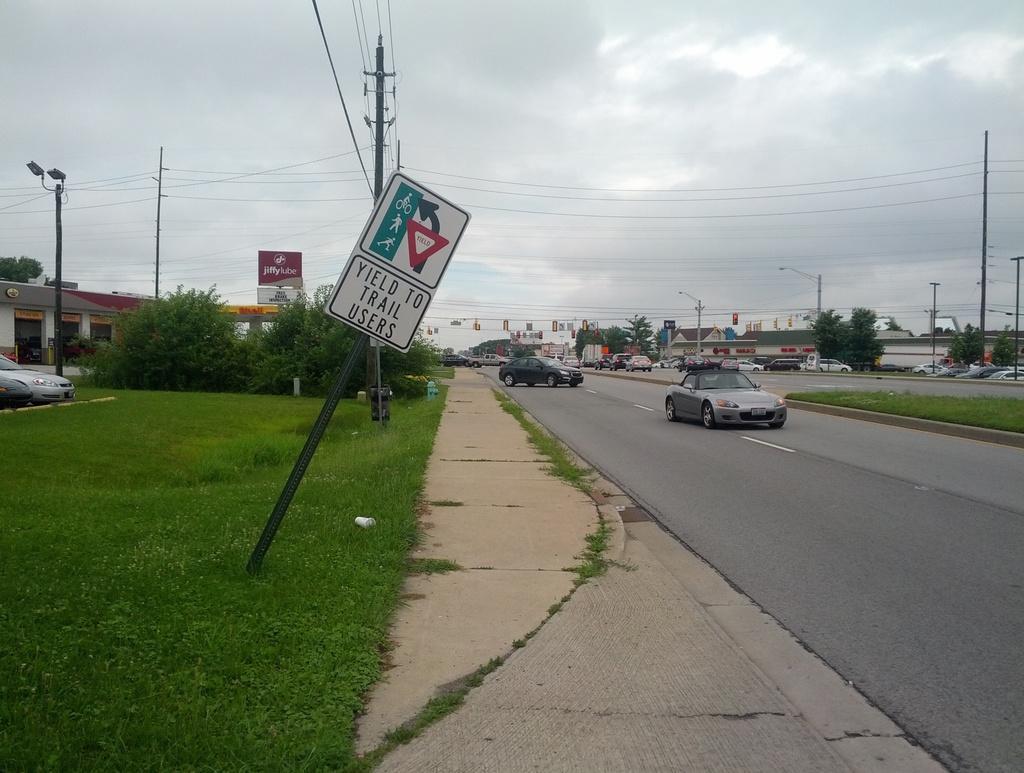Please provide a concise description of this image. In this picture, we can see a few vehicles, road, ground with grass, poles, lights, sign boards, signal lights, posters with some text, wires, building with windows, and the sky with clouds. 